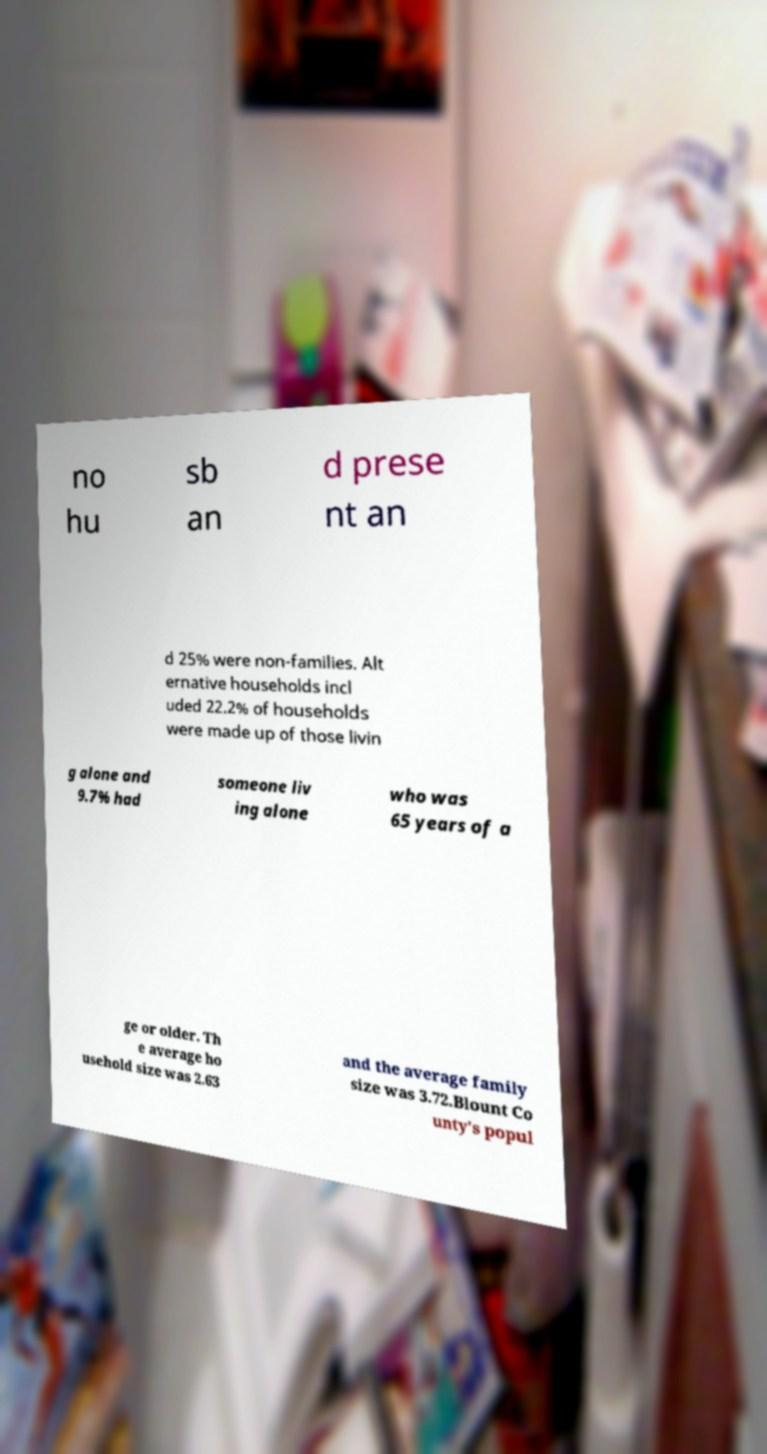Could you extract and type out the text from this image? no hu sb an d prese nt an d 25% were non-families. Alt ernative households incl uded 22.2% of households were made up of those livin g alone and 9.7% had someone liv ing alone who was 65 years of a ge or older. Th e average ho usehold size was 2.63 and the average family size was 3.72.Blount Co unty's popul 